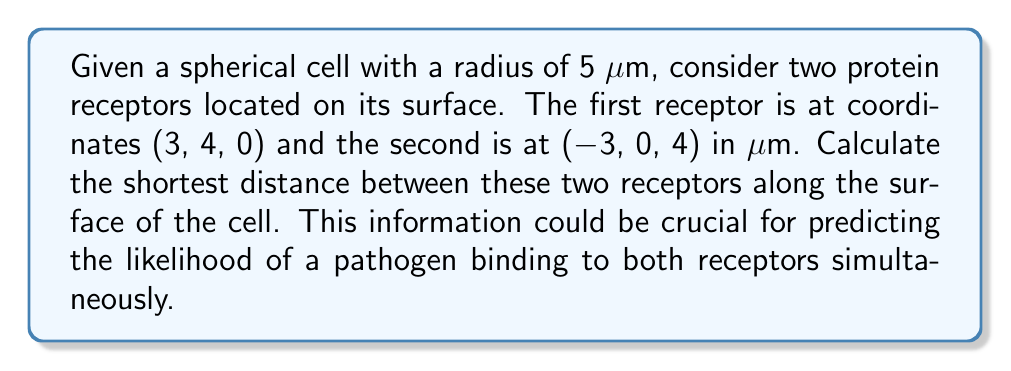Show me your answer to this math problem. To solve this problem, we need to use the concept of great circle distance on a sphere. The steps are as follows:

1) First, we need to convert the Cartesian coordinates to spherical coordinates (latitude and longitude). We can ignore the radial component as both points are on the surface.

   For point A (3, 4, 0):
   $$\phi_A = \arcsin(\frac{0}{5}) = 0$$
   $$\lambda_A = \arctan2(4, 3) = 0.9273 \text{ radians}$$

   For point B (-3, 0, 4):
   $$\phi_B = \arcsin(\frac{4}{5}) = 0.9273 \text{ radians}$$
   $$\lambda_B = \arctan2(0, -3) = \pi \text{ radians}$$

2) Now we can use the spherical law of cosines to find the central angle $\theta$ between these points:

   $$\cos(\theta) = \sin(\phi_A)\sin(\phi_B) + \cos(\phi_A)\cos(\phi_B)\cos(|\lambda_A - \lambda_B|)$$

3) Substituting our values:

   $$\cos(\theta) = \sin(0)\sin(0.9273) + \cos(0)\cos(0.9273)\cos(|0.9273 - \pi|)$$
   $$= 0 + \cos(0.9273)\cos(2.2143)$$
   $$= (0.5968)(-0.5968) = -0.3562$$

4) Taking the inverse cosine:

   $$\theta = \arccos(-0.3562) = 1.9307 \text{ radians}$$

5) The shortest distance $d$ along the surface is then the arc length:

   $$d = r\theta = 5 \cdot 1.9307 = 9.6535 \text{ μm}$$

Where $r$ is the radius of the sphere (cell).

[asy]
import geometry;

size(200);
draw(Circle((0,0),5));
dot((3,4),red);
dot((-3,0),red);
draw((3,4)--(-3,0),blue);
label("A",(3,4),NE);
label("B",(-3,0),NW);
draw(arc((0,0),5,0,110.6),green);
label("Shortest path",(-1,3),N,green);
[/asy]
Answer: The shortest distance between the two receptors along the surface of the spherical cell is approximately 9.65 μm. 